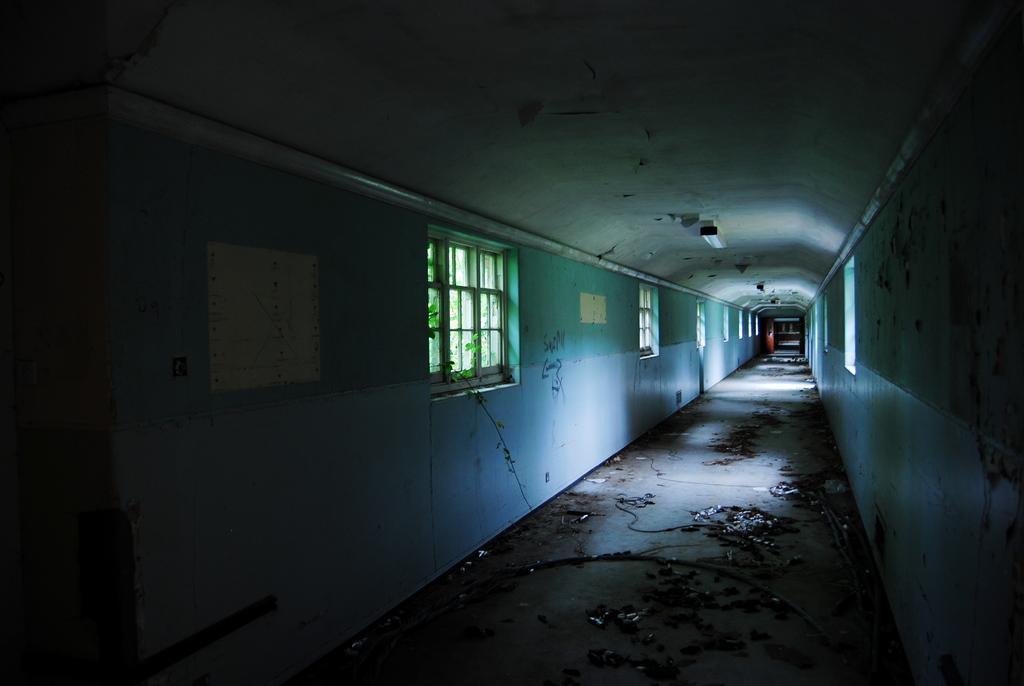Please provide a concise description of this image. In this image we can see there are walls, windows, plants and dirt on the ground. And at the top we can see the ceiling and light. 